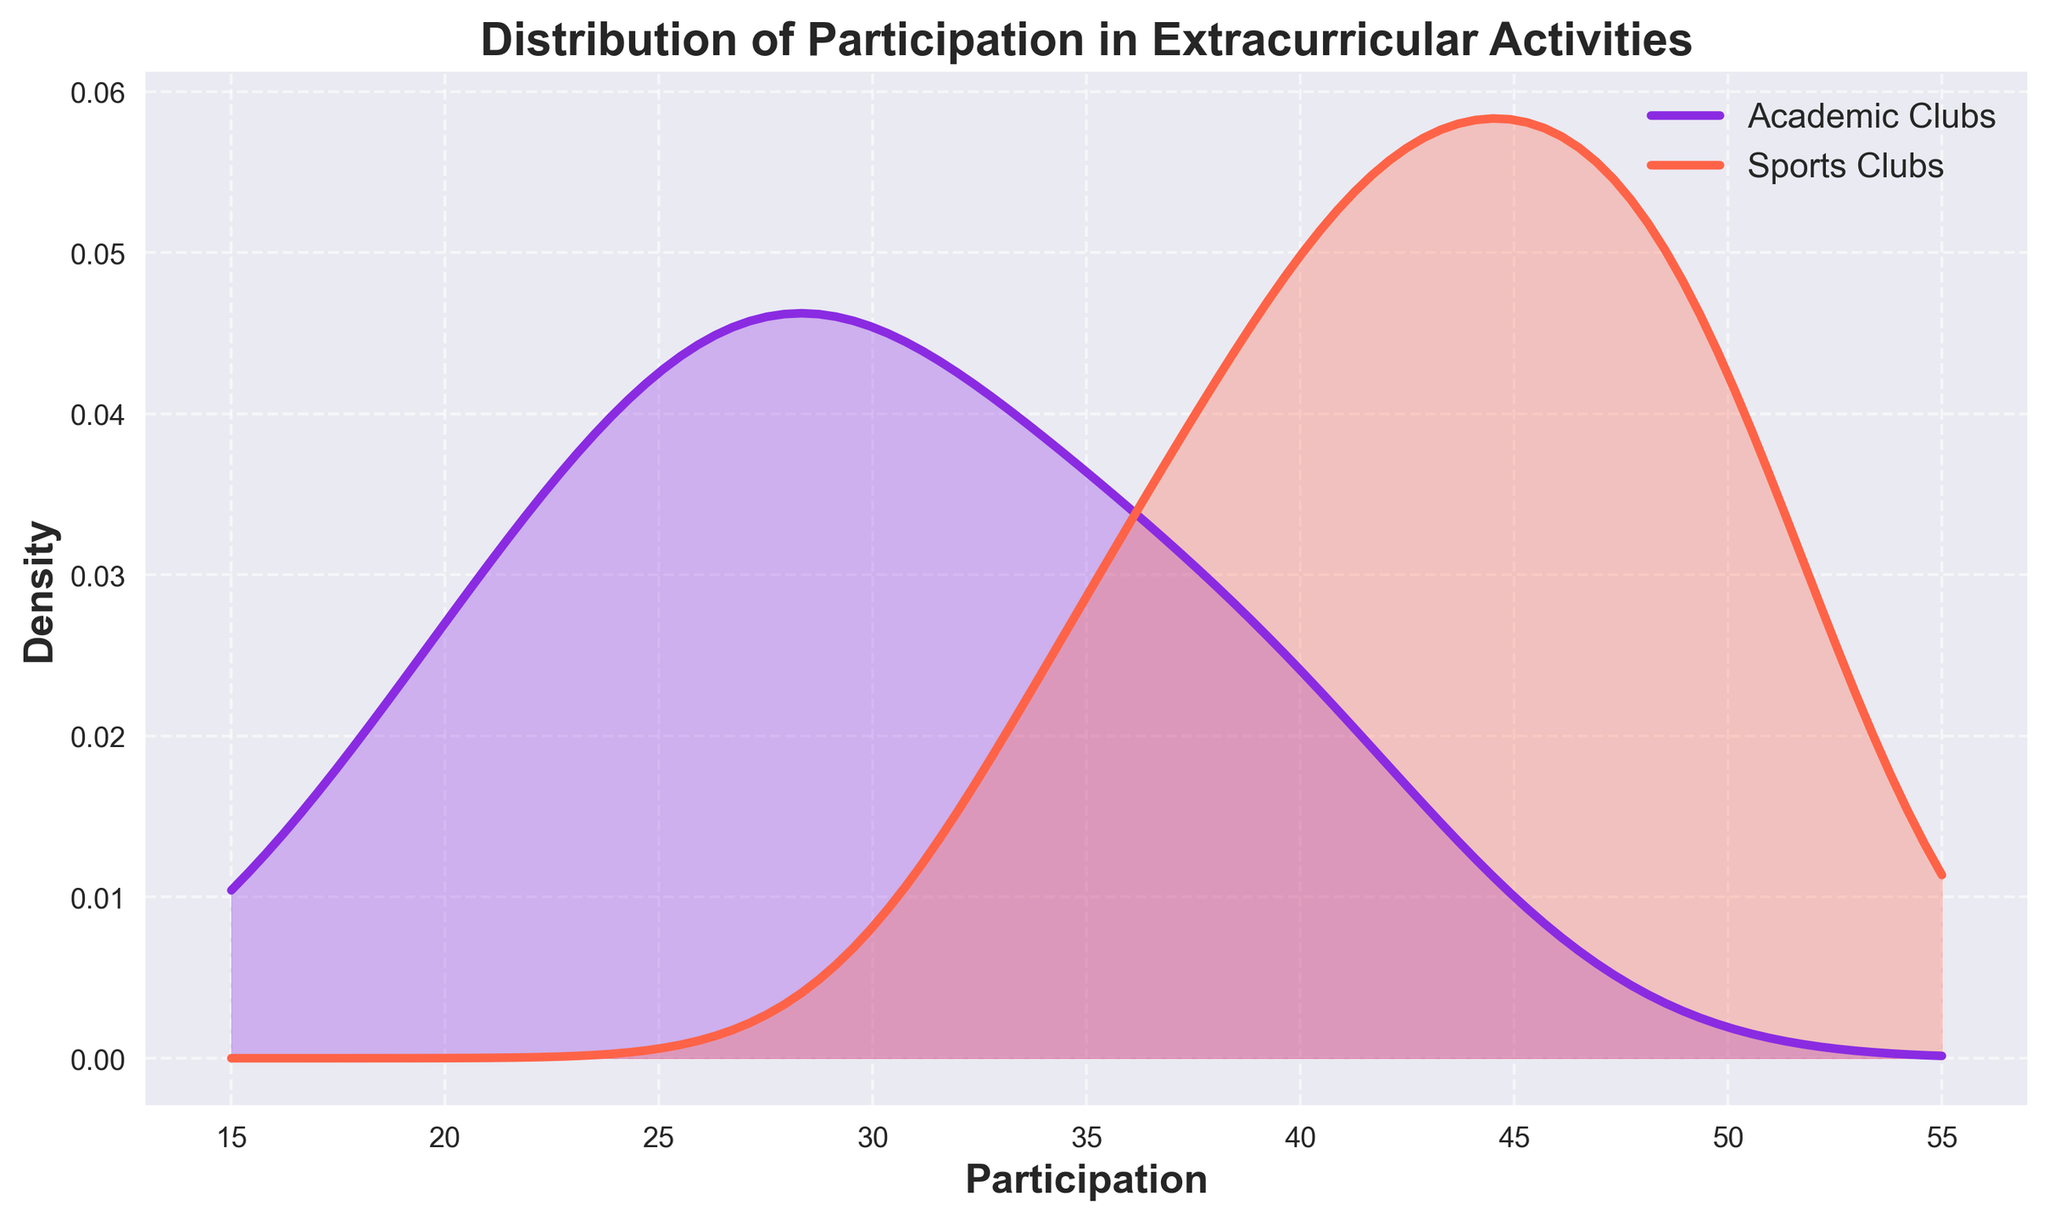What is the title of the plot? The title of the plot is displayed at the top of the figure. By reading it, we can determine the title.
Answer: Distribution of Participation in Extracurricular Activities What are the two types of activities compared in the plot? The labels in the legend indicate the two types of activities compared in the plot.
Answer: Academic Clubs and Sports Clubs Which type of activity has a peak density at around 40 participants? Observing the peaks of the density curves, we can identify that the curve with a peak around 40 participants belongs to the type specified in the legend.
Answer: Sports Clubs How does the density of participation in academic clubs compare to sports clubs at 30 participants? By examining the density curves at 30 participants, we can compare the height of the academic and sports density curves. The taller curve indicates a higher density.
Answer: Academic Clubs have higher density At approximately how many participants does the density curve for sports clubs start to decline? The density curve for sports clubs starts to decline after reaching its peak. By following the curve's trajectory, we can identify the approximate value where the decline begins.
Answer: Around 50 participants How do the ranges of participation in academic and sports clubs differ? By looking at the span of each density curve along the x-axis, we can determine the range of participation values for both types of activities.
Answer: Academic Clubs: ~20-40, Sports Clubs: ~30-50 Which type of activity shows more variability in participation? Variability can be inferred from the spread of the density curves. A wider curve indicates greater variability, whereas a narrower curve indicates less variability.
Answer: Sports Clubs What is the primary color used for the density curve of academic clubs? The legend and the color of the density curve for academic clubs indicate the primary color used.
Answer: Purple If you had to choose an activity with a participation density of 0.02 or higher, which range of participants in academic clubs would you look at? By identifying where the density curve for academic clubs intersects the 0.02 density level, we can determine the participant range that meets this criterion.
Answer: Around 30 to 35 participants What feature is included in the plot to help differentiate between the density curves of the two types of activities? The plot uses different colors and fills the area under each density curve with a semi-transparent hue to distinguish between the two types of activities.
Answer: Different colors and fill under curves 